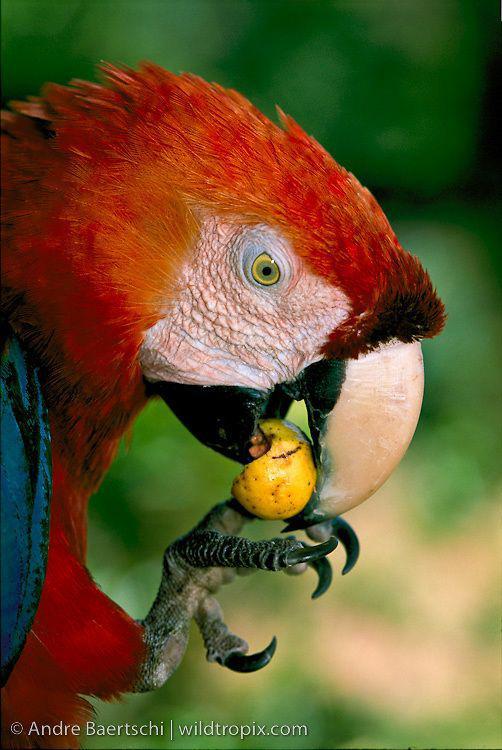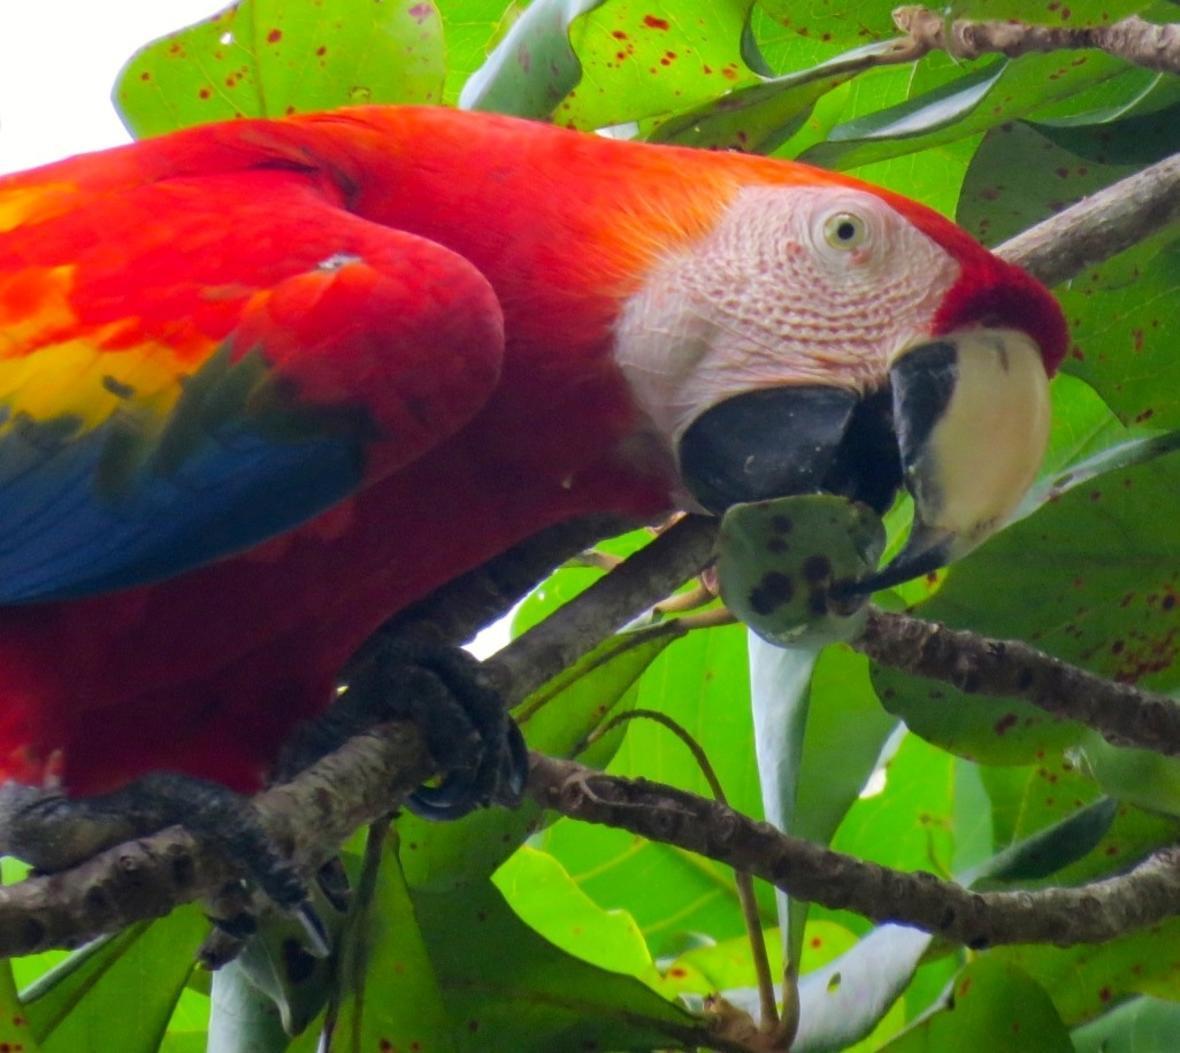The first image is the image on the left, the second image is the image on the right. For the images shown, is this caption "The birds in both images have predominantly blue and yellow coloring" true? Answer yes or no. No. The first image is the image on the left, the second image is the image on the right. For the images shown, is this caption "On one image, there's a parrot perched on a branch." true? Answer yes or no. Yes. 